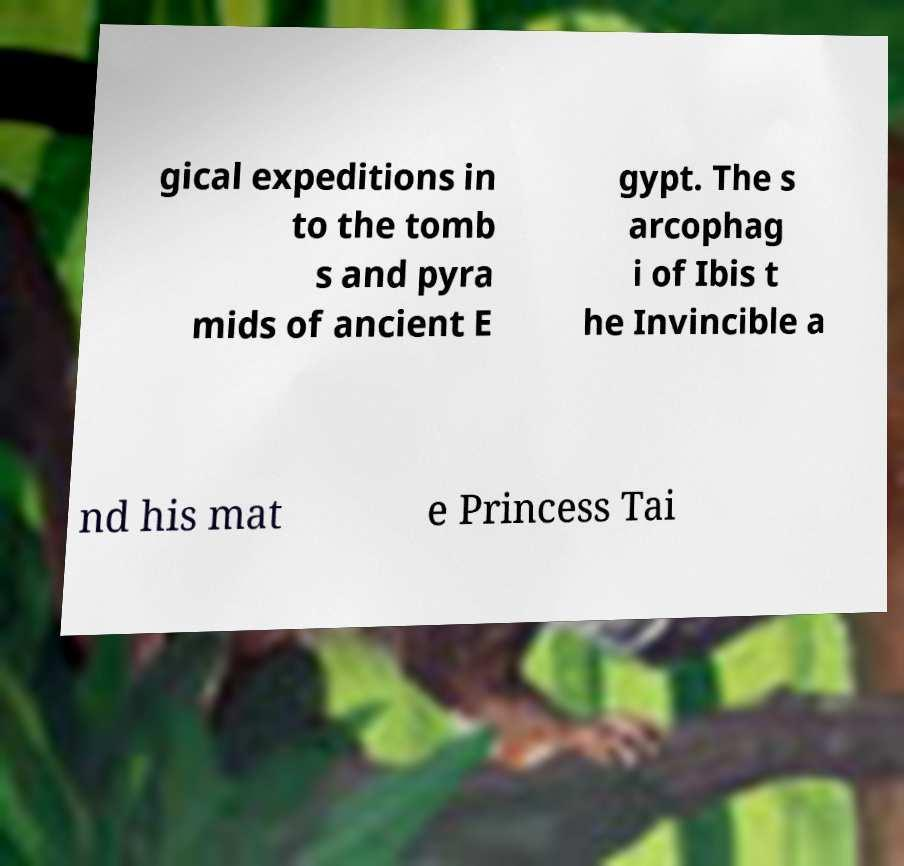Can you read and provide the text displayed in the image?This photo seems to have some interesting text. Can you extract and type it out for me? gical expeditions in to the tomb s and pyra mids of ancient E gypt. The s arcophag i of Ibis t he Invincible a nd his mat e Princess Tai 